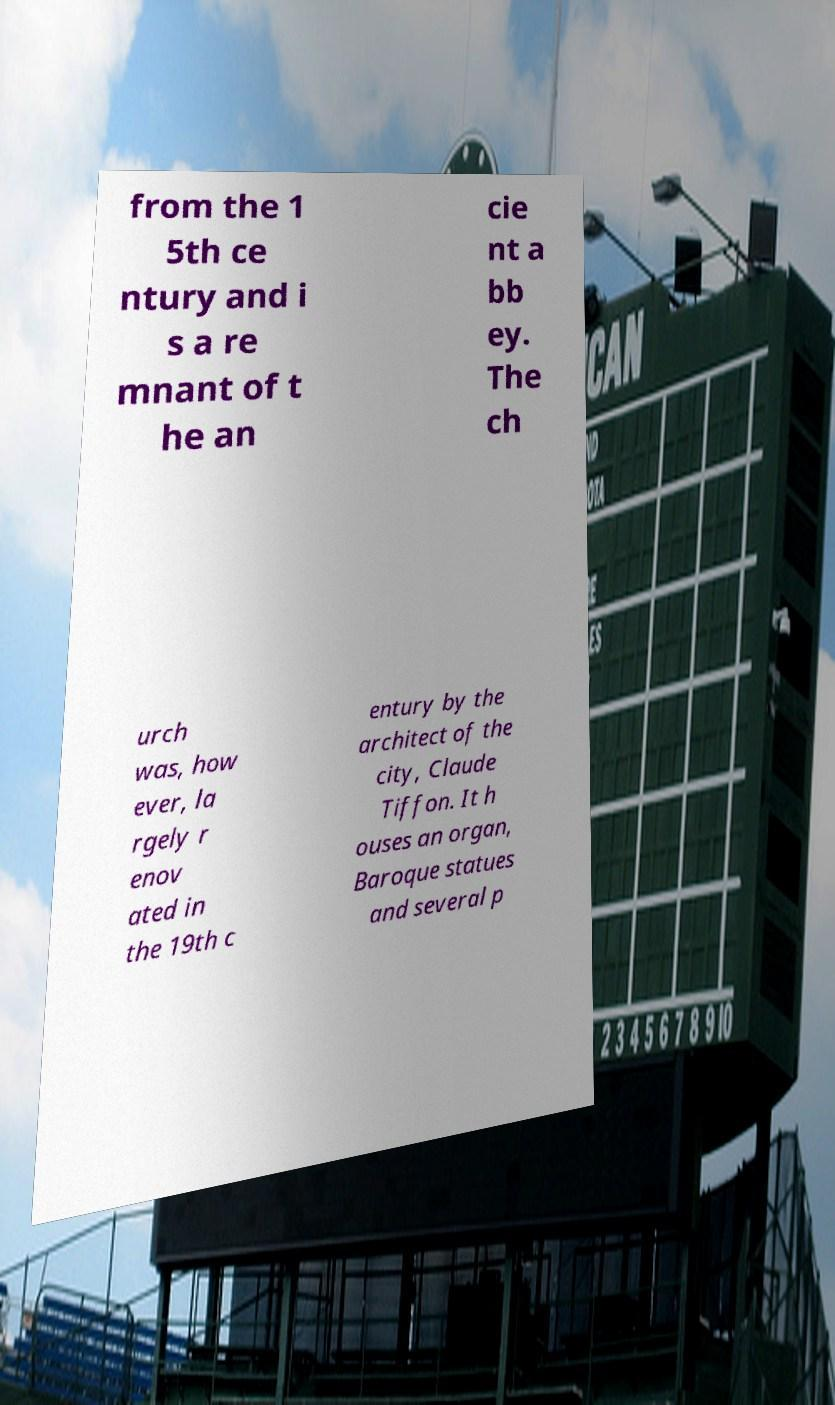For documentation purposes, I need the text within this image transcribed. Could you provide that? from the 1 5th ce ntury and i s a re mnant of t he an cie nt a bb ey. The ch urch was, how ever, la rgely r enov ated in the 19th c entury by the architect of the city, Claude Tiffon. It h ouses an organ, Baroque statues and several p 